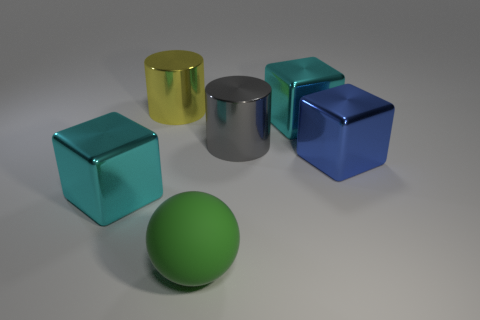Subtract all big blue cubes. How many cubes are left? 2 Subtract all cyan cubes. How many cubes are left? 1 Add 2 big yellow matte spheres. How many objects exist? 8 Subtract all spheres. How many objects are left? 5 Add 3 cyan blocks. How many cyan blocks exist? 5 Subtract 1 green spheres. How many objects are left? 5 Subtract 2 cubes. How many cubes are left? 1 Subtract all green blocks. Subtract all yellow cylinders. How many blocks are left? 3 Subtract all cyan balls. How many purple cylinders are left? 0 Subtract all blue shiny cylinders. Subtract all large balls. How many objects are left? 5 